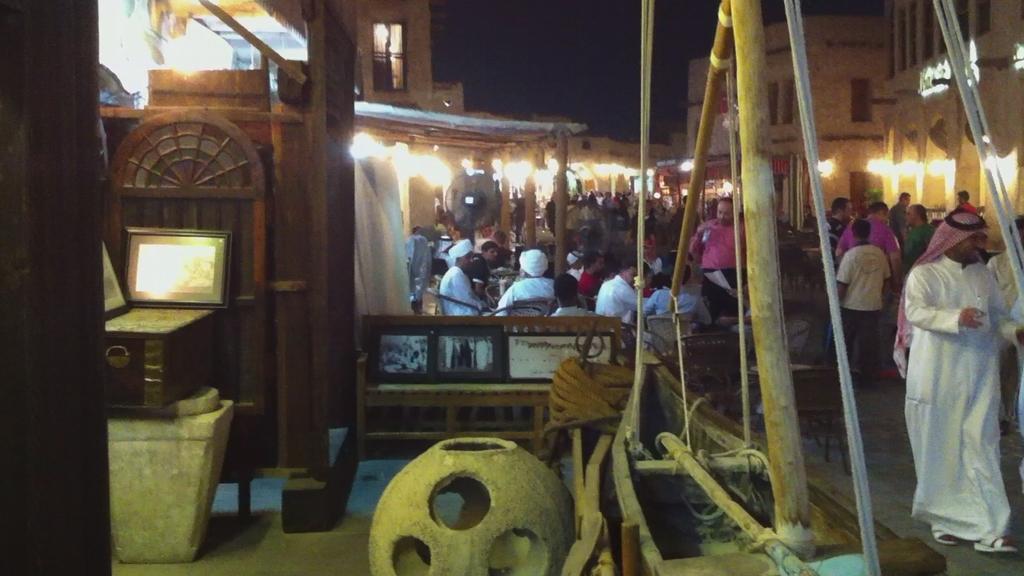In one or two sentences, can you explain what this image depicts? In this image I can see there is crowd on the right side , beside the crowd there is a building there is a light focus visible in front of building, in the foreground there are some threads and wooden table and there are some objects , in the foreground there is a pot kept on floor. 